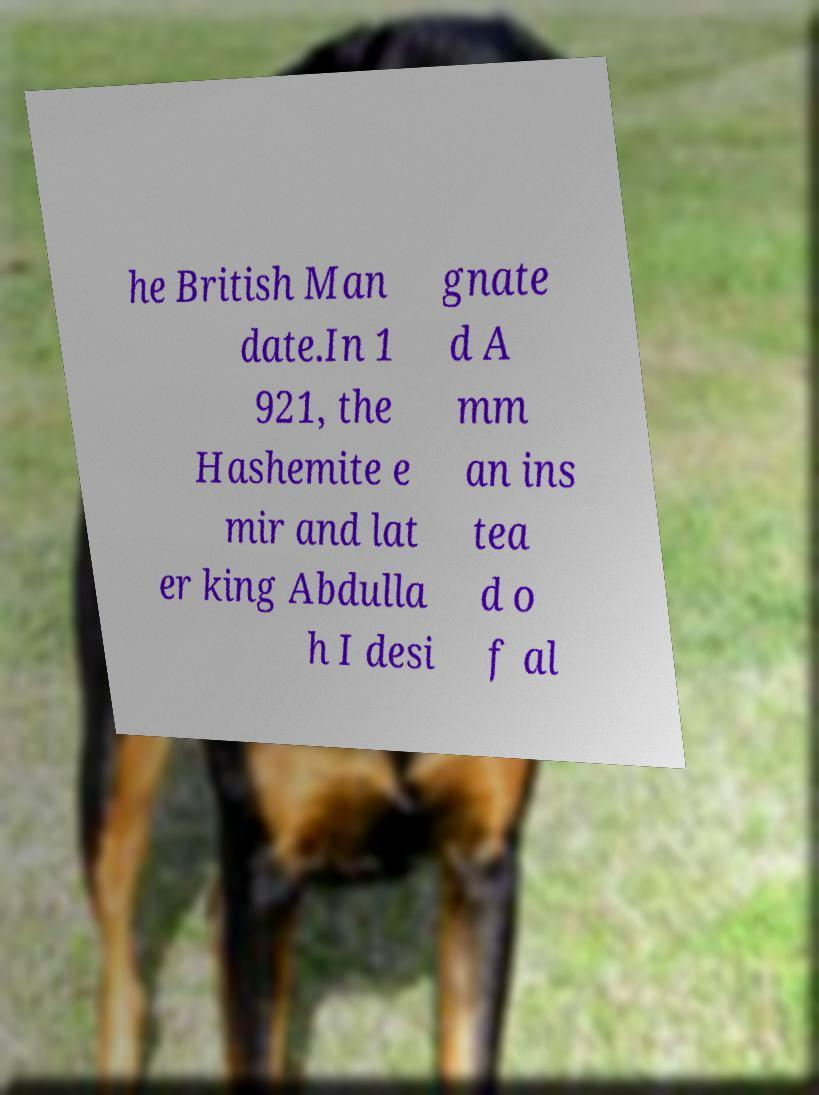Could you extract and type out the text from this image? he British Man date.In 1 921, the Hashemite e mir and lat er king Abdulla h I desi gnate d A mm an ins tea d o f al 